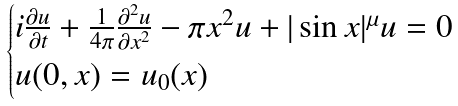<formula> <loc_0><loc_0><loc_500><loc_500>\begin{cases} i \frac { \partial u } { \partial t } + \frac { 1 } { 4 \pi } \frac { \partial ^ { 2 } u } { \partial x ^ { 2 } } - \pi x ^ { 2 } u + | \sin x | ^ { \mu } u = 0 \\ u ( 0 , x ) = u _ { 0 } ( x ) \end{cases}</formula> 